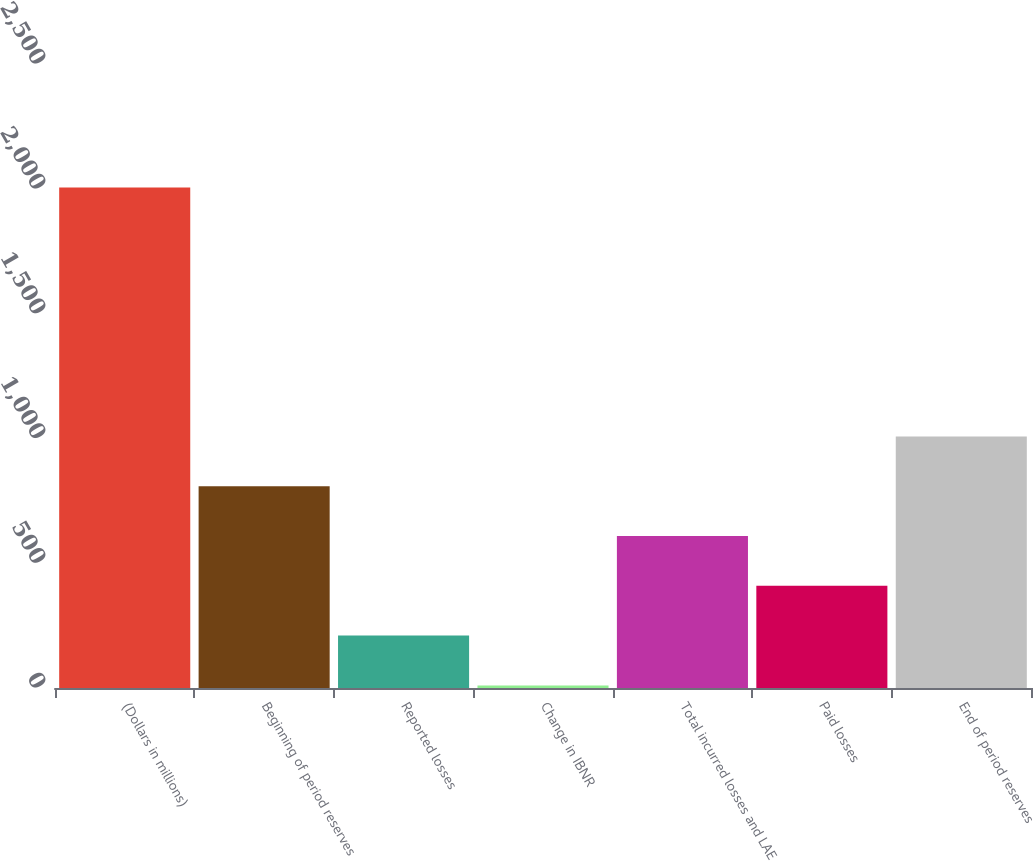Convert chart to OTSL. <chart><loc_0><loc_0><loc_500><loc_500><bar_chart><fcel>(Dollars in millions)<fcel>Beginning of period reserves<fcel>Reported losses<fcel>Change in IBNR<fcel>Total incurred losses and LAE<fcel>Paid losses<fcel>End of period reserves<nl><fcel>2005<fcel>808.24<fcel>209.86<fcel>10.4<fcel>608.78<fcel>409.32<fcel>1007.7<nl></chart> 